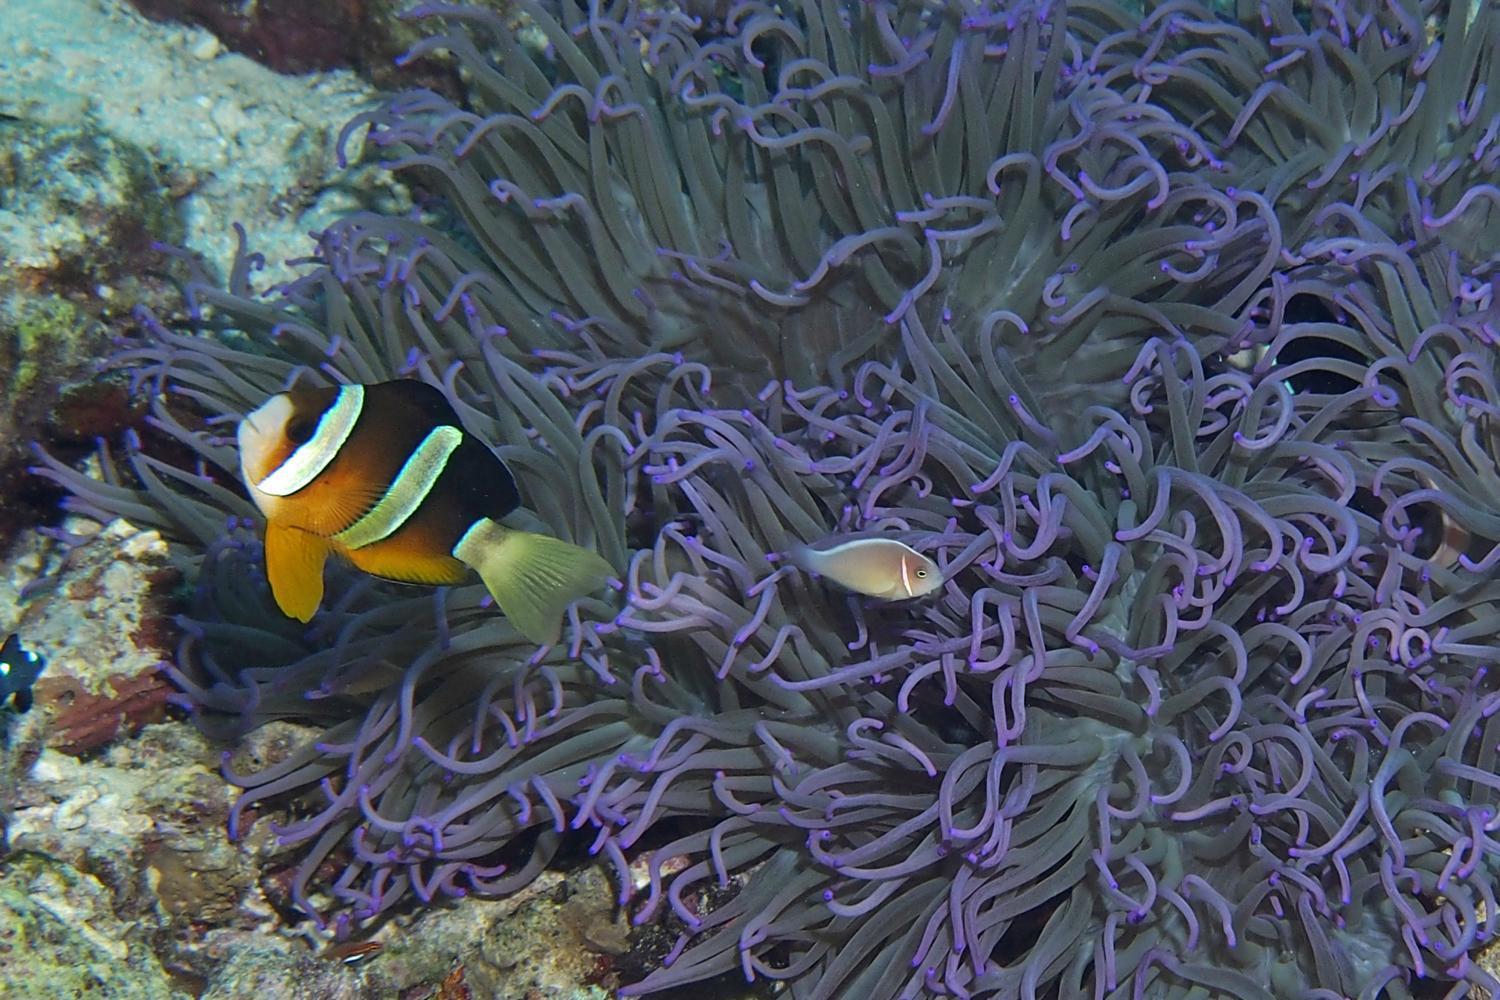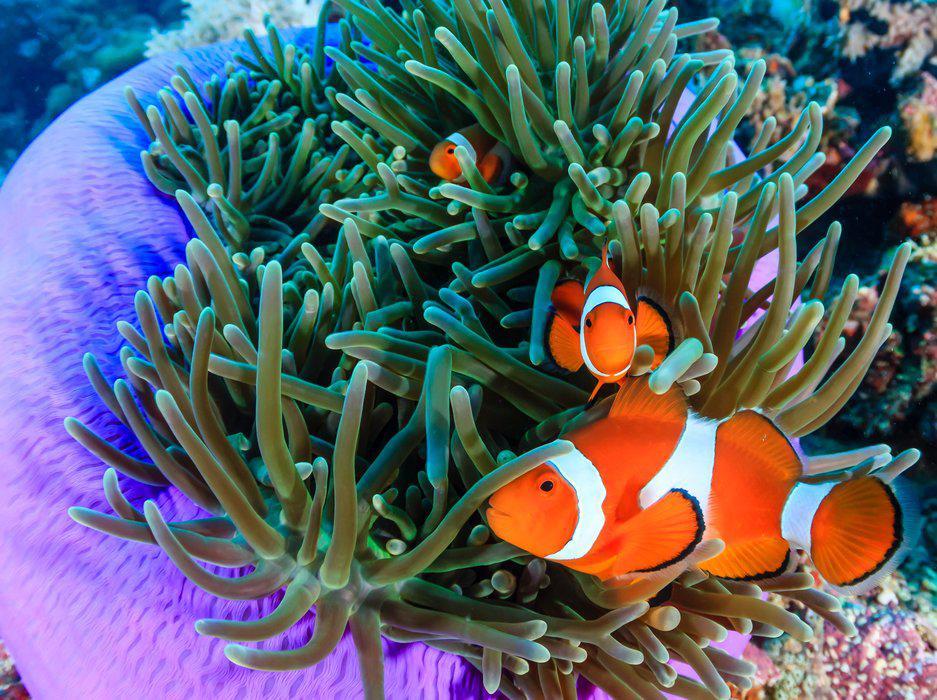The first image is the image on the left, the second image is the image on the right. For the images shown, is this caption "In at least one image, there is a single purple round corral underneath green corral arms that fish are swimming through." true? Answer yes or no. Yes. The first image is the image on the left, the second image is the image on the right. Analyze the images presented: Is the assertion "The right image shows at least two orange fish swimming in tendrils that sprout from an anemone's round purple stalk." valid? Answer yes or no. Yes. 